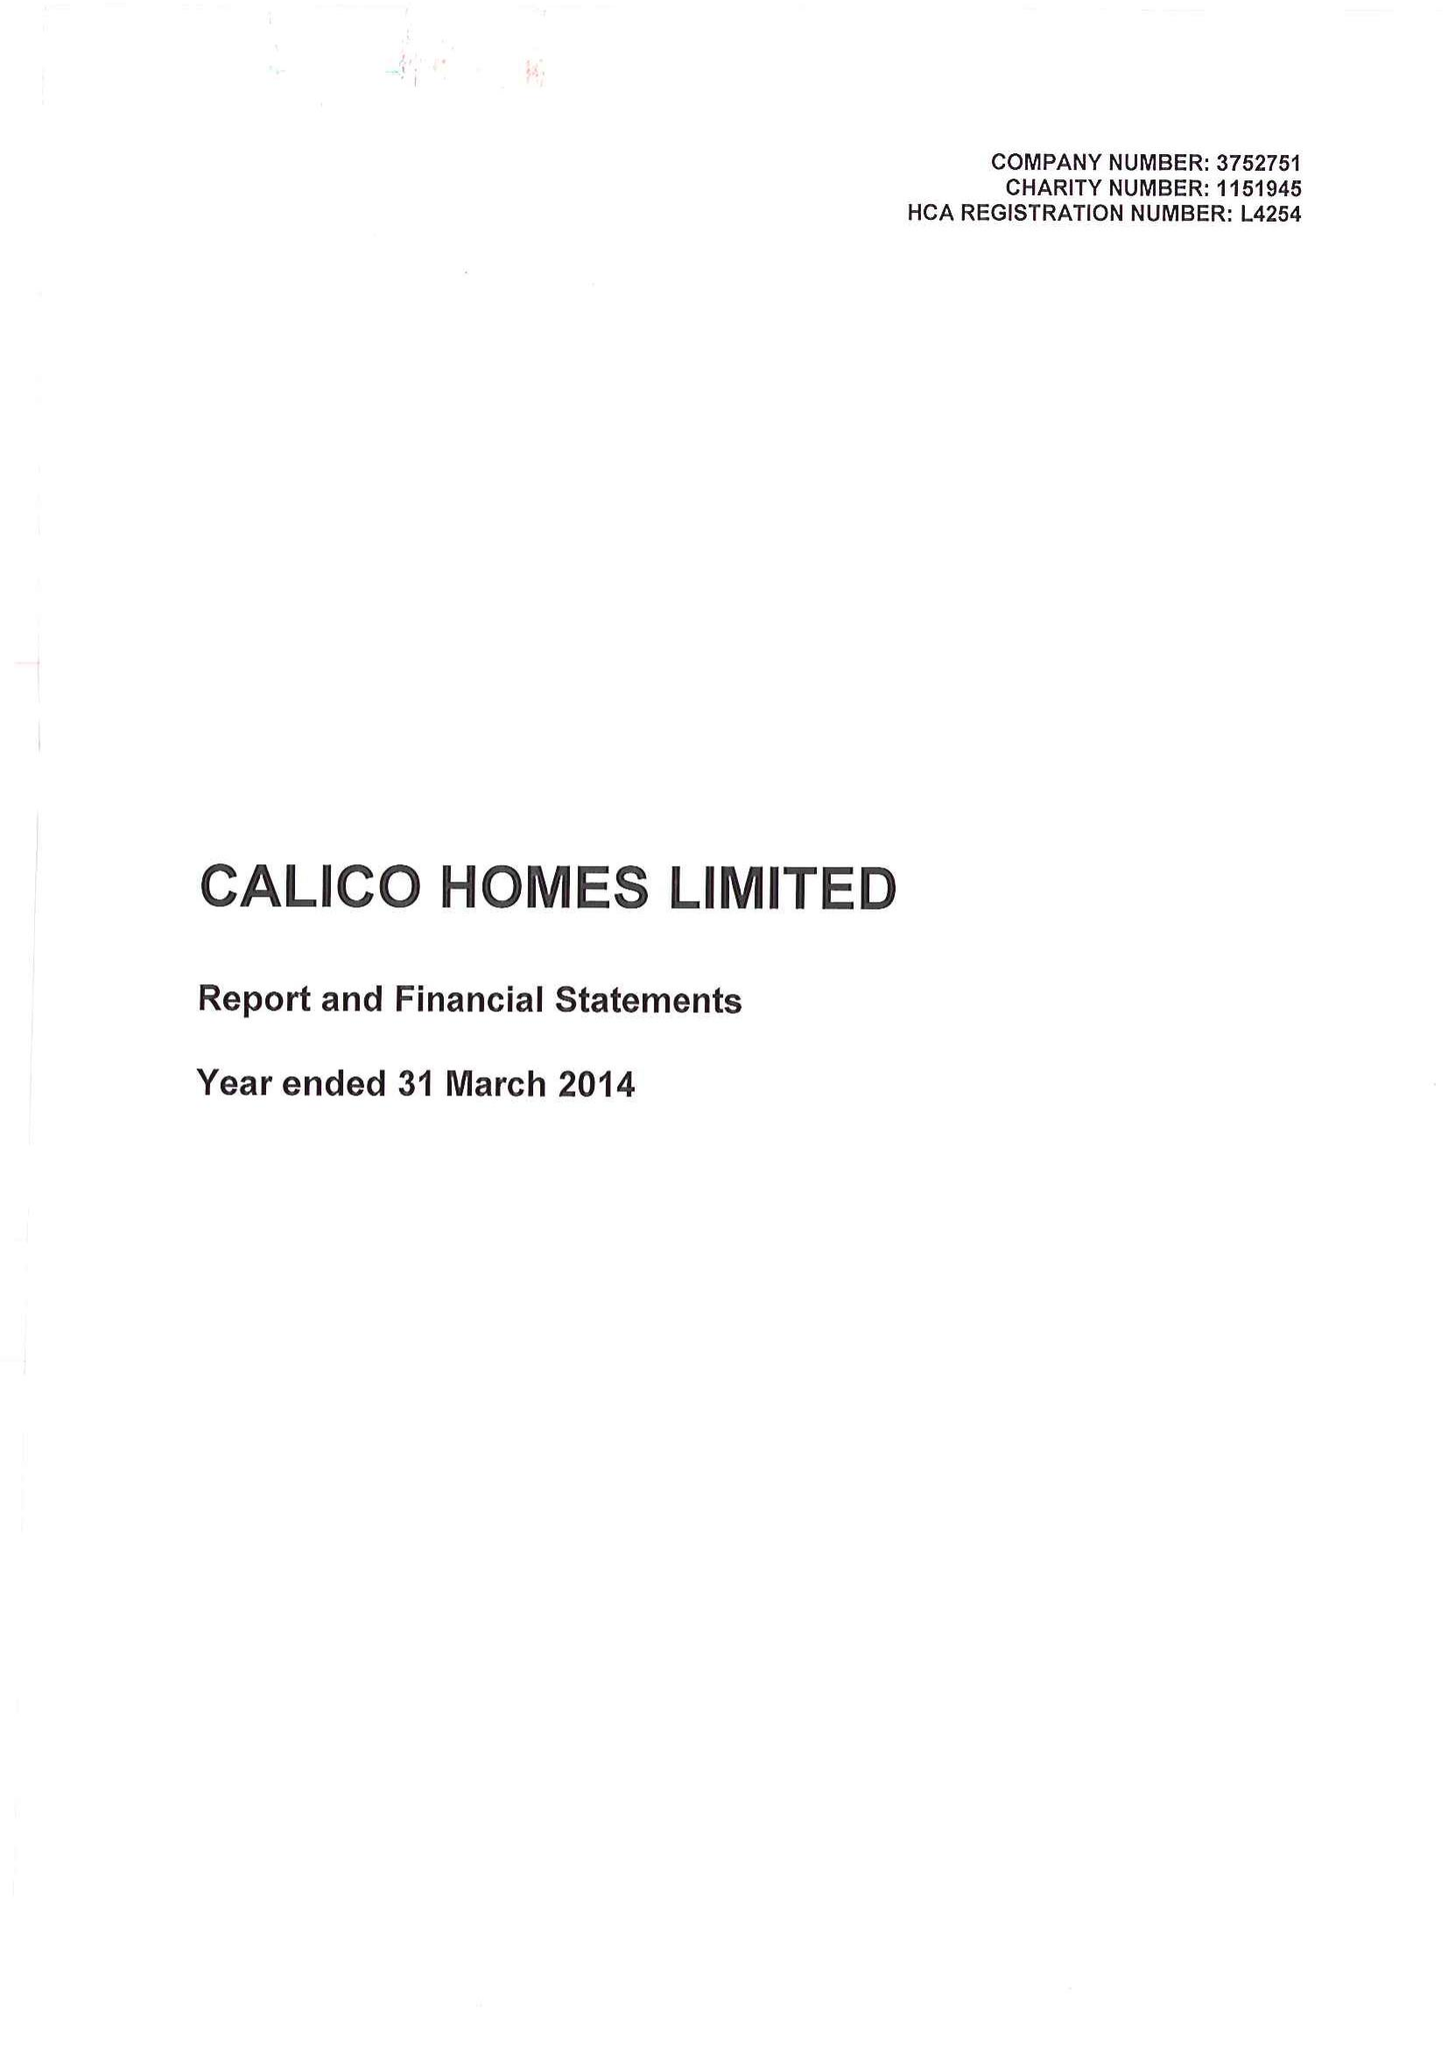What is the value for the address__post_town?
Answer the question using a single word or phrase. BURNLEY 